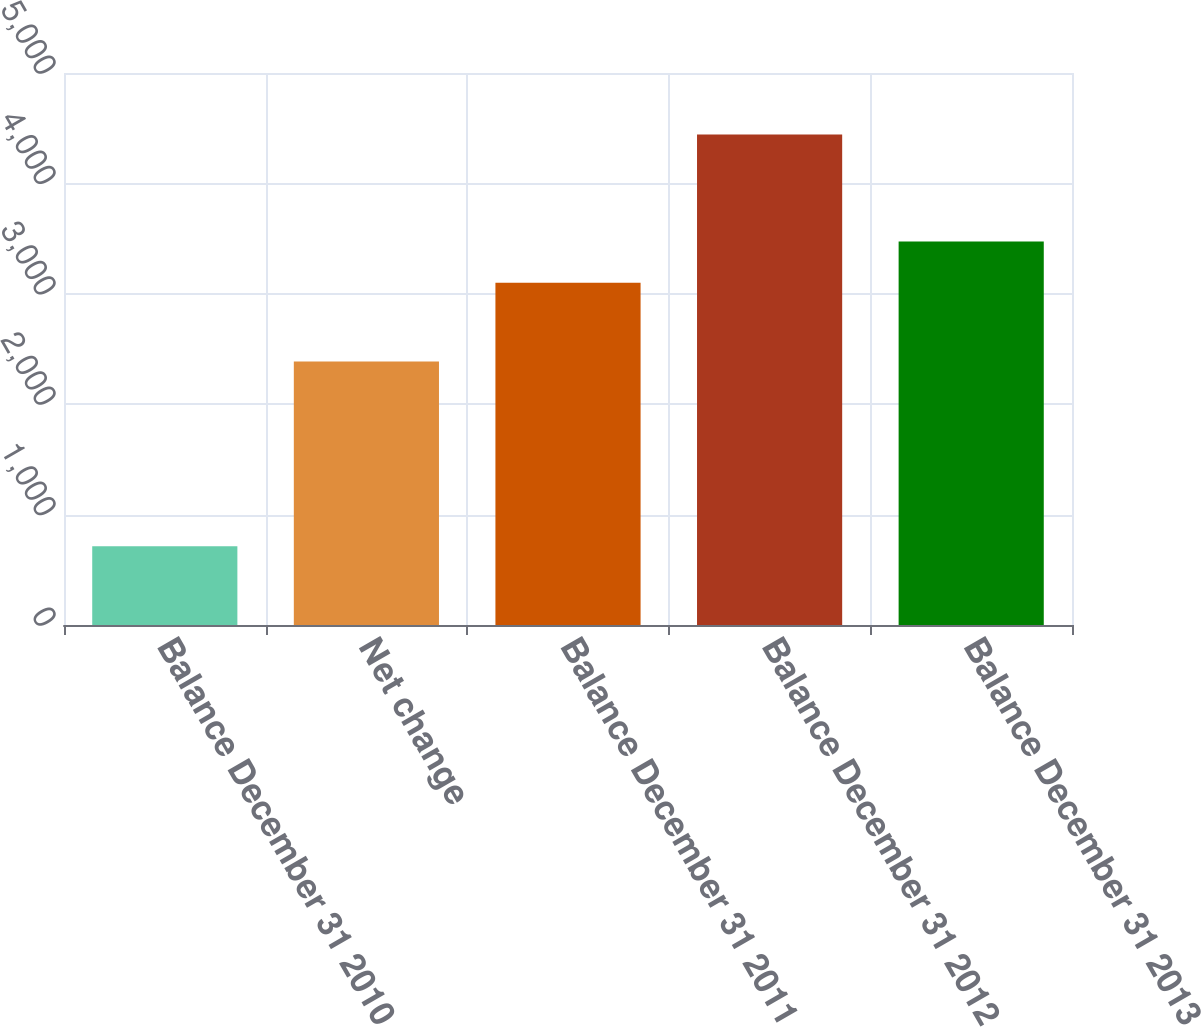Convert chart to OTSL. <chart><loc_0><loc_0><loc_500><loc_500><bar_chart><fcel>Balance December 31 2010<fcel>Net change<fcel>Balance December 31 2011<fcel>Balance December 31 2012<fcel>Balance December 31 2013<nl><fcel>714<fcel>2386<fcel>3100<fcel>4443<fcel>3472.9<nl></chart> 